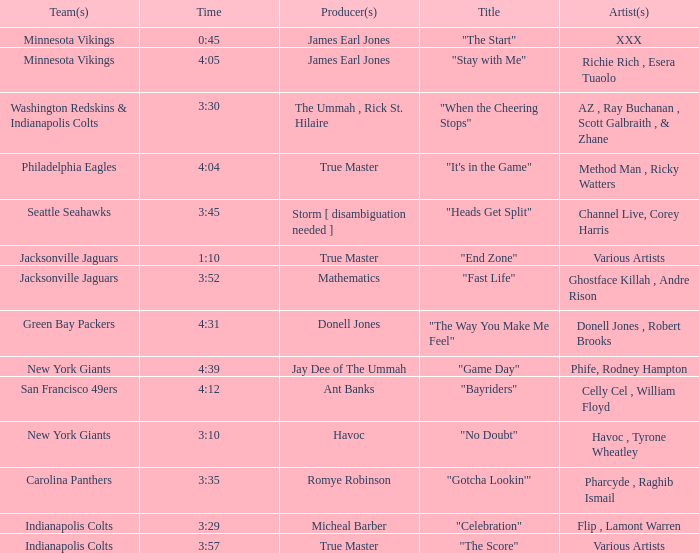What teams employed a track with a 3:29 duration? Indianapolis Colts. 